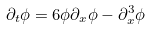<formula> <loc_0><loc_0><loc_500><loc_500>\partial _ { t } \phi = 6 \phi \partial _ { x } \phi - \partial _ { x } ^ { 3 } \phi</formula> 